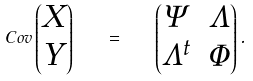Convert formula to latex. <formula><loc_0><loc_0><loc_500><loc_500>C o v \begin{pmatrix} X \\ Y \end{pmatrix} \quad = \quad \begin{pmatrix} \Psi & \Lambda \\ \Lambda ^ { t } & \Phi \end{pmatrix} .</formula> 